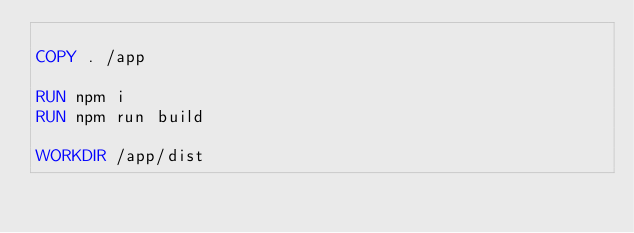<code> <loc_0><loc_0><loc_500><loc_500><_Dockerfile_>
COPY . /app

RUN npm i
RUN npm run build

WORKDIR /app/dist

</code> 